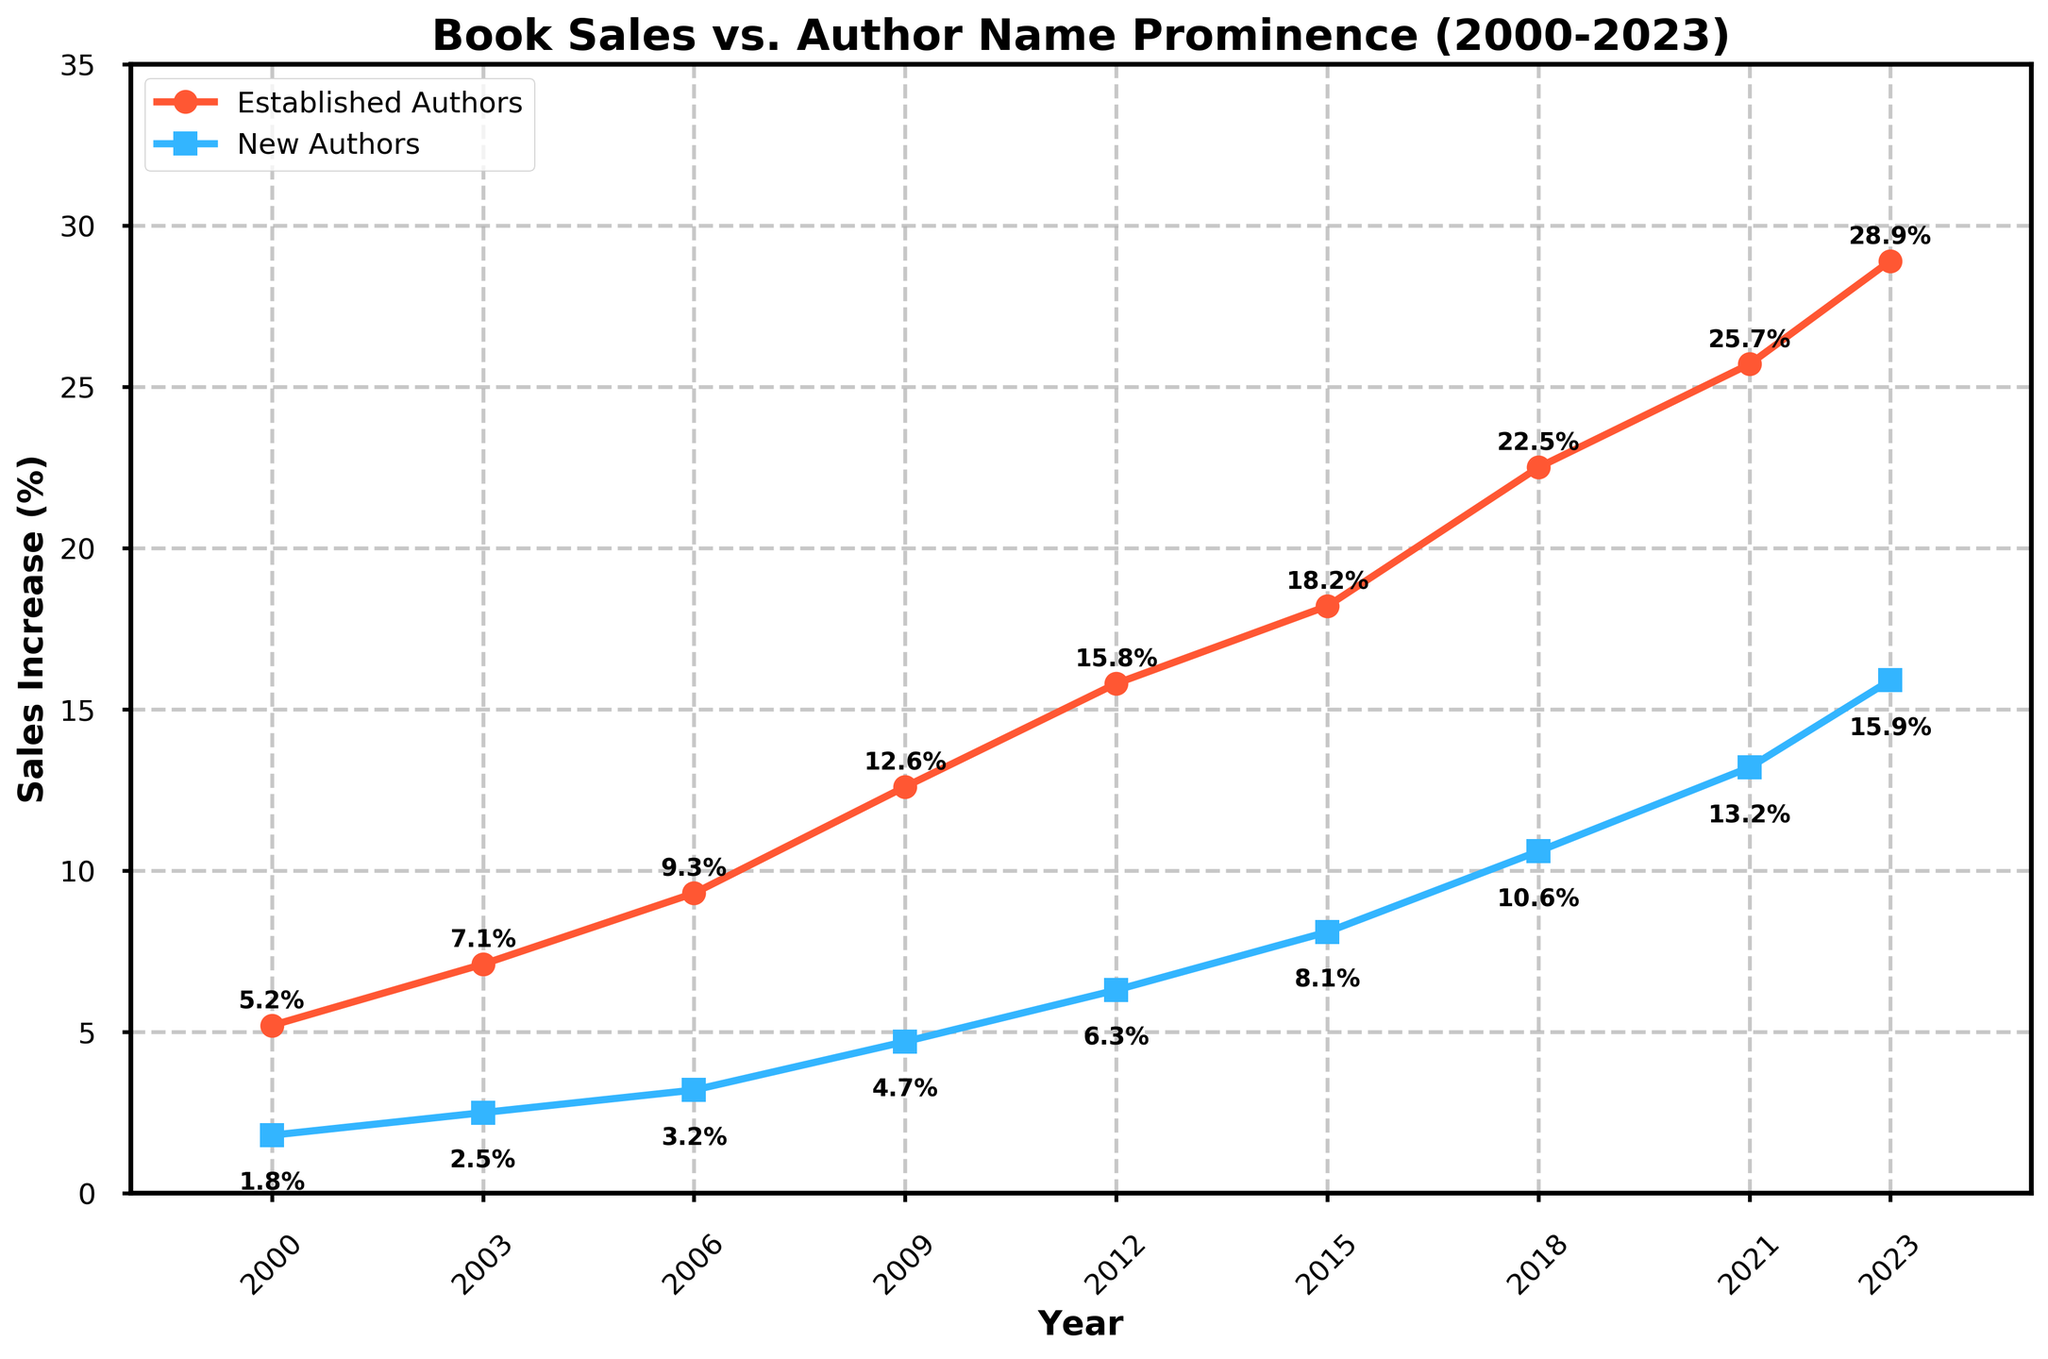What is the sales increase for established authors in 2021? According to the line labeled 'Established Authors,' the sales increase percentage for 2021 marked on the graph is 25.7%.
Answer: 25.7% What is the difference in sales increase between established authors and new authors in 2023? In 2023, the sales increase for established authors is 28.9%, and for new authors, it is 15.9%. The difference is 28.9% - 15.9% = 13%.
Answer: 13% Which year had the highest sales increase for new authors? By examining the 'New Authors' line, the highest point appears in the year 2023, with a sales increase of 15.9%.
Answer: 2023 In which year did established authors' sales increase reach 12.6%? The sales increase for established authors reaches 12.6% in the year 2009. This can be seen directly from the labeled points on the graph.
Answer: 2009 Compare the sales increase of new authors in 2006 and 2009. Which year shows a greater increase? Looking at the 'New Authors' line, 2009 marks a sales increase of 4.7%, while 2006 shows an increase of 3.2%. Thus, 2009 has a greater increase.
Answer: 2009 By how much did the sales increase for new authors between 2015 and 2021? In 2015, the increase for new authors is 8.1%, and in 2021, it is 13.2%. The difference is 13.2% - 8.1% = 5.1%.
Answer: 5.1% Between which consecutive years did established authors see the largest increase in sales? By checking the slopes of the line for 'Established Authors', the largest jump is between 2018 and 2021, where sales increased from 22.5% to 25.7%. The increase is 25.7% - 22.5% = 3.2%.
Answer: 2018-2021 What is the combined sales increase for both established and new authors in 2012? In 2012, the sales increase is 15.8% for established authors and 6.3% for new authors. Adding these together: 15.8% + 6.3% = 22.1%.
Answer: 22.1% Which category of authors shows a consistently larger increase in sales over the years? By examining the two lines, 'Established Authors' consistently show a larger increase in sales compared to 'New Authors' across all years from 2000 to 2023.
Answer: Established Authors How much did the sales increase for established authors over the entire period from 2000 to 2023? The increase for established authors in 2000 was 5.2%, and in 2023 it was 28.9%. The total increase over the period is 28.9% - 5.2% = 23.7%.
Answer: 23.7% 